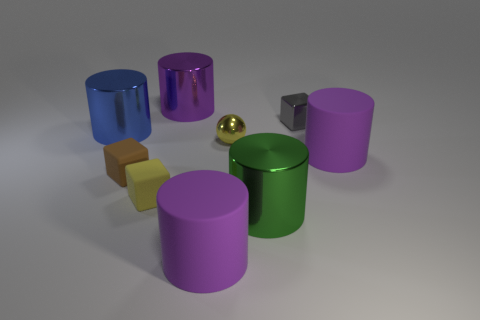Subtract all cyan blocks. How many purple cylinders are left? 3 Subtract all blue cylinders. How many cylinders are left? 4 Subtract all big blue cylinders. How many cylinders are left? 4 Subtract all red cylinders. Subtract all red balls. How many cylinders are left? 5 Add 1 gray shiny cubes. How many objects exist? 10 Subtract all blocks. How many objects are left? 6 Subtract 0 cyan cylinders. How many objects are left? 9 Subtract all big purple matte cylinders. Subtract all purple rubber things. How many objects are left? 5 Add 9 small gray objects. How many small gray objects are left? 10 Add 7 small metal objects. How many small metal objects exist? 9 